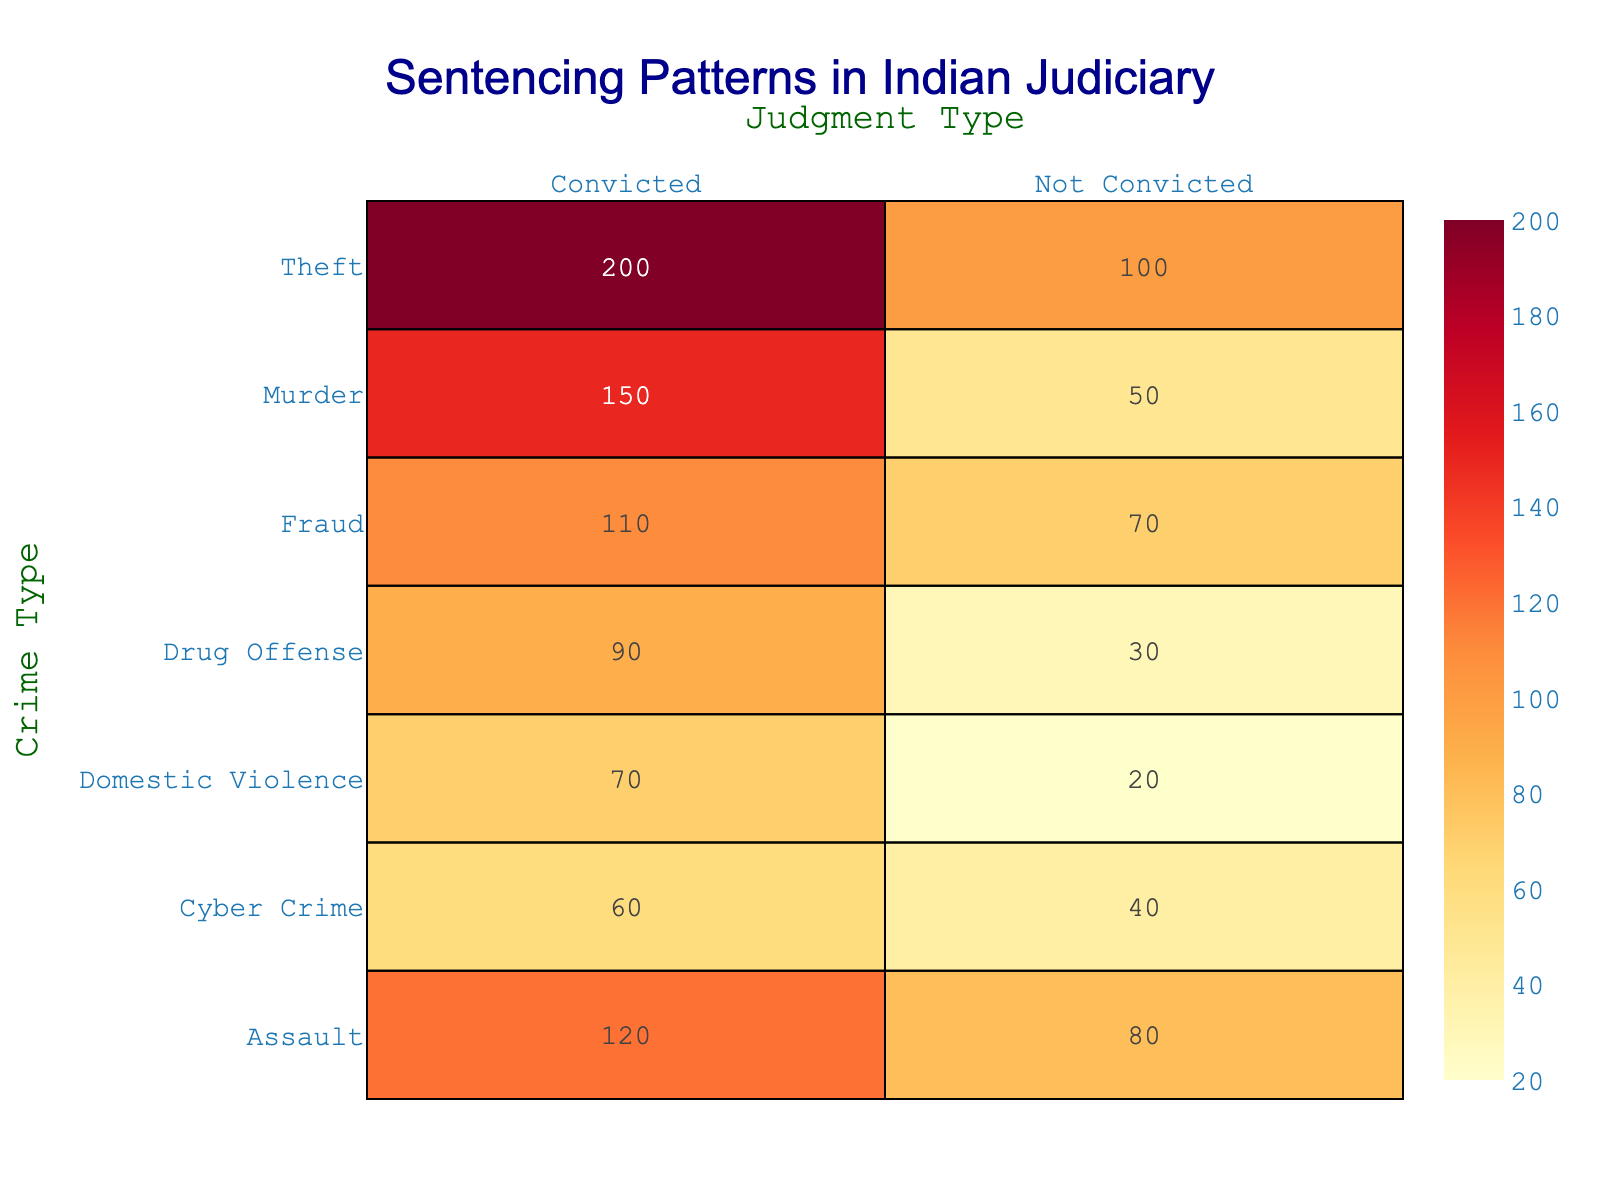What is the total number of convicted cases for Drug Offense? In the table, for Drug Offense under the Convicted category, the count is 90. Therefore, the total number of convicted cases for Drug Offense is directly found from the table.
Answer: 90 What is the total number of not convicted cases across all crime types? To find the total number of not convicted cases, we need to sum the "Not Convicted" counts from all crime types: 50 (Murder) + 100 (Theft) + 80 (Assault) + 30 (Drug Offense) + 40 (Cyber Crime) + 20 (Domestic Violence) + 70 (Fraud) = 390.
Answer: 390 Is the number of convicted cases for Theft greater than the number of convicted cases for Assault? From the table, the count for convicted Theft is 200, while for Assault it is 120. Because 200 is greater than 120, the statement is true.
Answer: Yes What is the ratio of convicted to not convicted cases for Domestic Violence? The convicted cases for Domestic Violence are 70, and the not convicted cases are 20. The ratio can be calculated as 70/20 = 3.5.
Answer: 3.5 Which crime type has the highest number of total convictions? To determine this, we sum the numbers for convicted cases for each crime type: Murder (150) + Theft (200) + Assault (120) + Drug Offense (90) + Cyber Crime (60) + Domestic Violence (70) + Fraud (110) = 900. The highest individual count is Theft with 200.
Answer: Theft How many more people were convicted for Theft than for Drug Offense? The number of convicted Theft is 200, and for Drug Offense, it is 90. The difference is calculated as 200 - 90 = 110.
Answer: 110 What percentage of total Murder cases resulted in convictions? Total Murder cases are 150 (Convicted) + 50 (Not Convicted) = 200. The percentage of convictions can be calculated as (150/200) * 100 = 75%.
Answer: 75% Which judgment type has the lowest total count across all crime types? First, we sum the counts for all judgment types: Convicted = 150 + 200 + 120 + 90 + 60 + 70 + 110 = 900; Not Convicted = 50 + 100 + 80 + 30 + 40 + 20 + 70 = 390. The lowest total is for Not Convicted with 390.
Answer: Not Convicted If the total number of cases for Assault is divided equally between convicted and not convicted, how many would that be? The total cases for Assault is 120 (Convicted) + 80 (Not Convicted) = 200. If divided equally, we would have 200/2 = 100 for each category.
Answer: 100 